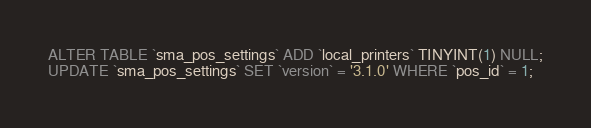Convert code to text. <code><loc_0><loc_0><loc_500><loc_500><_SQL_>ALTER TABLE `sma_pos_settings` ADD `local_printers` TINYINT(1) NULL;
UPDATE `sma_pos_settings` SET `version` = '3.1.0' WHERE `pos_id` = 1;
</code> 